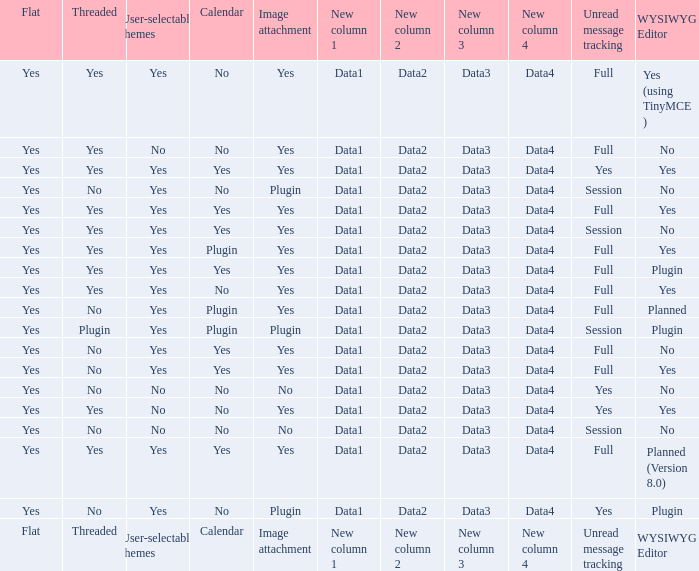Which Calendar has a User-selectable themes of user-selectable themes? Calendar. 